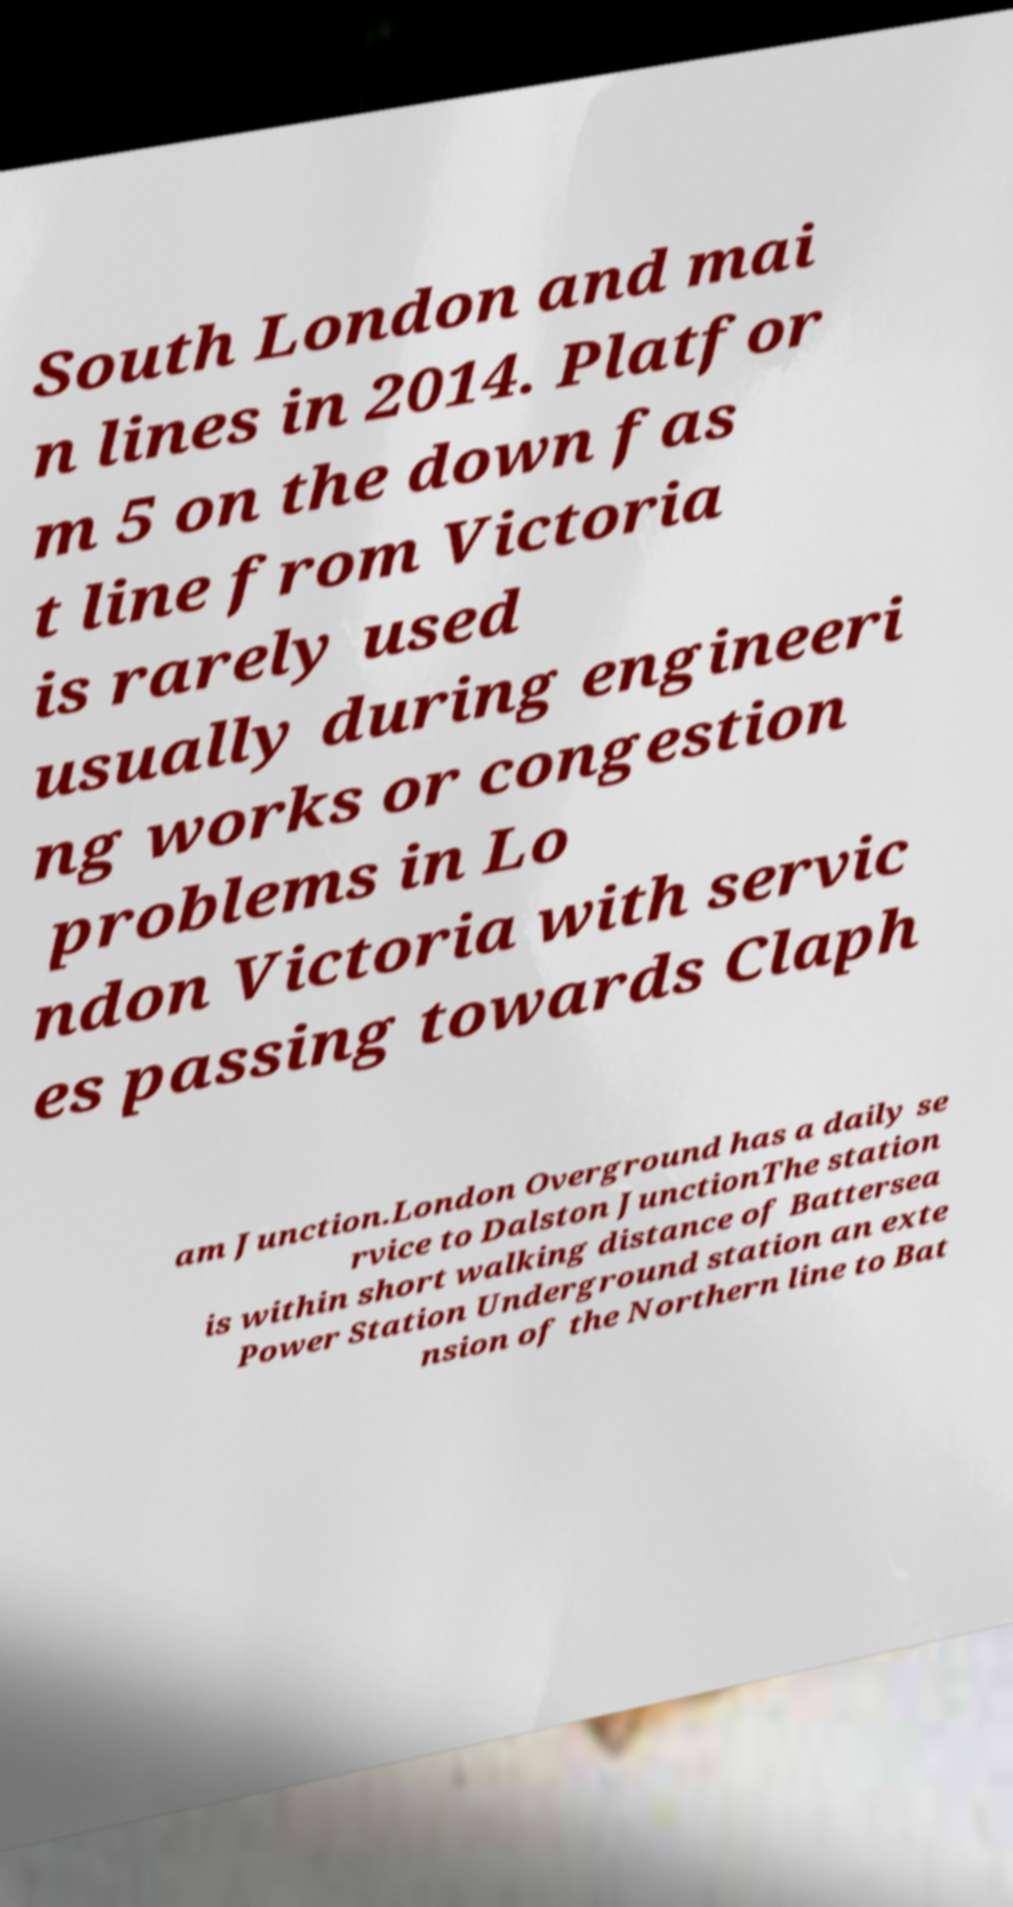Please identify and transcribe the text found in this image. South London and mai n lines in 2014. Platfor m 5 on the down fas t line from Victoria is rarely used usually during engineeri ng works or congestion problems in Lo ndon Victoria with servic es passing towards Claph am Junction.London Overground has a daily se rvice to Dalston JunctionThe station is within short walking distance of Battersea Power Station Underground station an exte nsion of the Northern line to Bat 